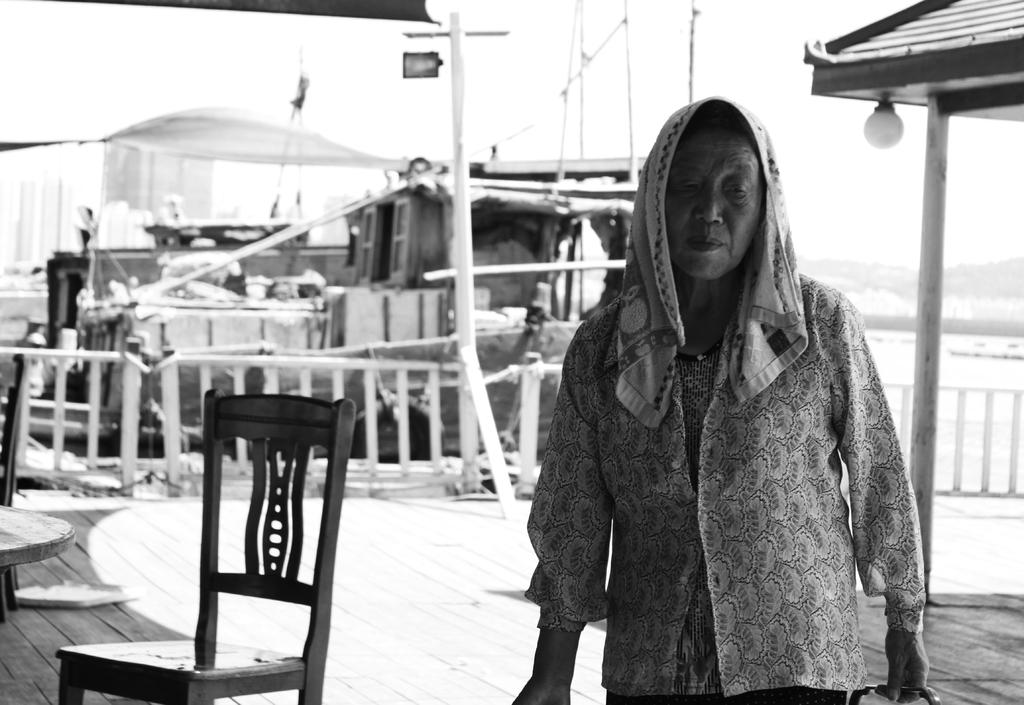What is the person in the image holding? There is a person holding an object in the image. What can be seen in the background of the image? There is a chair and a boat on the water in the background of the image. What is the color scheme of the image? The image is in black and white. What is the name of the chicken in the image? There is no chicken present in the image. What type of alarm is going off in the image? There is no alarm present in the image. 